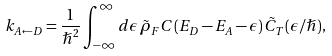<formula> <loc_0><loc_0><loc_500><loc_500>k _ { A \leftarrow D } = \frac { 1 } { \hslash ^ { 2 } } \int _ { - \infty } ^ { \infty } d \epsilon \, \tilde { \rho } _ { F } C ( E _ { D } - E _ { A } - \epsilon ) \, \tilde { C } _ { T } ( \epsilon / \hslash ) ,</formula> 